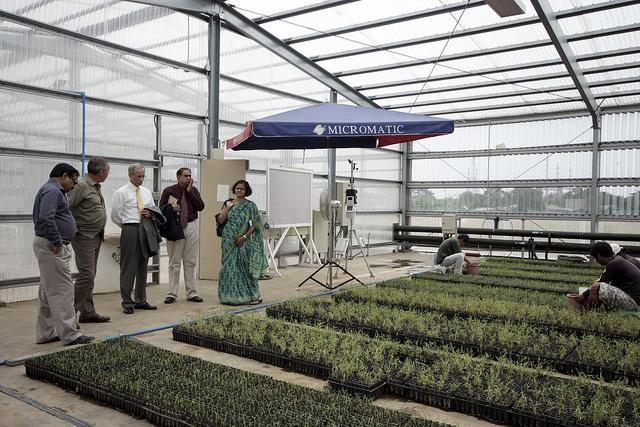What might the temperature be like where they are standing? Please explain your reasoning. humid. Greenhouses are kept hot and humid to promote the growth of the plants. 